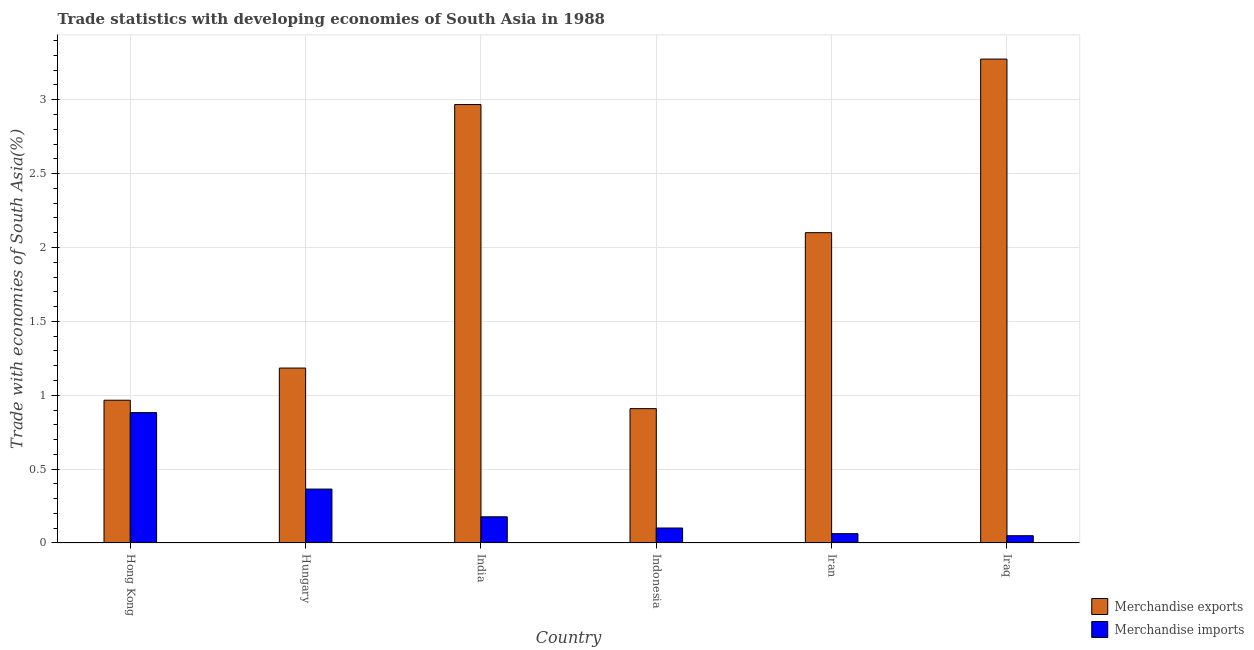How many different coloured bars are there?
Your answer should be very brief. 2. Are the number of bars on each tick of the X-axis equal?
Keep it short and to the point. Yes. How many bars are there on the 2nd tick from the left?
Make the answer very short. 2. How many bars are there on the 3rd tick from the right?
Keep it short and to the point. 2. What is the label of the 5th group of bars from the left?
Offer a very short reply. Iran. In how many cases, is the number of bars for a given country not equal to the number of legend labels?
Ensure brevity in your answer.  0. What is the merchandise exports in Iran?
Your answer should be very brief. 2.1. Across all countries, what is the maximum merchandise imports?
Provide a short and direct response. 0.88. Across all countries, what is the minimum merchandise imports?
Keep it short and to the point. 0.05. In which country was the merchandise exports maximum?
Provide a short and direct response. Iraq. In which country was the merchandise imports minimum?
Provide a succinct answer. Iraq. What is the total merchandise exports in the graph?
Offer a terse response. 11.4. What is the difference between the merchandise exports in Hungary and that in India?
Keep it short and to the point. -1.78. What is the difference between the merchandise exports in Indonesia and the merchandise imports in India?
Your response must be concise. 0.73. What is the average merchandise imports per country?
Provide a succinct answer. 0.27. What is the difference between the merchandise exports and merchandise imports in Iraq?
Your response must be concise. 3.23. What is the ratio of the merchandise exports in Hong Kong to that in Iran?
Keep it short and to the point. 0.46. Is the merchandise exports in Hong Kong less than that in Iran?
Provide a succinct answer. Yes. What is the difference between the highest and the second highest merchandise exports?
Offer a very short reply. 0.31. What is the difference between the highest and the lowest merchandise imports?
Your response must be concise. 0.83. What does the 2nd bar from the right in Hungary represents?
Offer a terse response. Merchandise exports. How many bars are there?
Make the answer very short. 12. How many countries are there in the graph?
Give a very brief answer. 6. How many legend labels are there?
Provide a short and direct response. 2. How are the legend labels stacked?
Ensure brevity in your answer.  Vertical. What is the title of the graph?
Offer a terse response. Trade statistics with developing economies of South Asia in 1988. What is the label or title of the Y-axis?
Provide a short and direct response. Trade with economies of South Asia(%). What is the Trade with economies of South Asia(%) of Merchandise exports in Hong Kong?
Ensure brevity in your answer.  0.97. What is the Trade with economies of South Asia(%) of Merchandise imports in Hong Kong?
Provide a succinct answer. 0.88. What is the Trade with economies of South Asia(%) of Merchandise exports in Hungary?
Your answer should be very brief. 1.18. What is the Trade with economies of South Asia(%) in Merchandise imports in Hungary?
Make the answer very short. 0.36. What is the Trade with economies of South Asia(%) in Merchandise exports in India?
Keep it short and to the point. 2.97. What is the Trade with economies of South Asia(%) in Merchandise imports in India?
Your answer should be compact. 0.18. What is the Trade with economies of South Asia(%) of Merchandise exports in Indonesia?
Your response must be concise. 0.91. What is the Trade with economies of South Asia(%) in Merchandise imports in Indonesia?
Your answer should be compact. 0.1. What is the Trade with economies of South Asia(%) in Merchandise exports in Iran?
Keep it short and to the point. 2.1. What is the Trade with economies of South Asia(%) in Merchandise imports in Iran?
Make the answer very short. 0.06. What is the Trade with economies of South Asia(%) in Merchandise exports in Iraq?
Offer a terse response. 3.27. What is the Trade with economies of South Asia(%) in Merchandise imports in Iraq?
Keep it short and to the point. 0.05. Across all countries, what is the maximum Trade with economies of South Asia(%) in Merchandise exports?
Make the answer very short. 3.27. Across all countries, what is the maximum Trade with economies of South Asia(%) in Merchandise imports?
Your response must be concise. 0.88. Across all countries, what is the minimum Trade with economies of South Asia(%) of Merchandise exports?
Offer a terse response. 0.91. Across all countries, what is the minimum Trade with economies of South Asia(%) of Merchandise imports?
Provide a succinct answer. 0.05. What is the total Trade with economies of South Asia(%) of Merchandise exports in the graph?
Offer a terse response. 11.4. What is the total Trade with economies of South Asia(%) in Merchandise imports in the graph?
Keep it short and to the point. 1.64. What is the difference between the Trade with economies of South Asia(%) of Merchandise exports in Hong Kong and that in Hungary?
Provide a succinct answer. -0.22. What is the difference between the Trade with economies of South Asia(%) in Merchandise imports in Hong Kong and that in Hungary?
Provide a succinct answer. 0.52. What is the difference between the Trade with economies of South Asia(%) in Merchandise exports in Hong Kong and that in India?
Offer a terse response. -2. What is the difference between the Trade with economies of South Asia(%) in Merchandise imports in Hong Kong and that in India?
Provide a short and direct response. 0.71. What is the difference between the Trade with economies of South Asia(%) of Merchandise exports in Hong Kong and that in Indonesia?
Keep it short and to the point. 0.06. What is the difference between the Trade with economies of South Asia(%) in Merchandise imports in Hong Kong and that in Indonesia?
Offer a very short reply. 0.78. What is the difference between the Trade with economies of South Asia(%) of Merchandise exports in Hong Kong and that in Iran?
Keep it short and to the point. -1.13. What is the difference between the Trade with economies of South Asia(%) in Merchandise imports in Hong Kong and that in Iran?
Provide a short and direct response. 0.82. What is the difference between the Trade with economies of South Asia(%) of Merchandise exports in Hong Kong and that in Iraq?
Keep it short and to the point. -2.31. What is the difference between the Trade with economies of South Asia(%) of Merchandise imports in Hong Kong and that in Iraq?
Your answer should be compact. 0.83. What is the difference between the Trade with economies of South Asia(%) in Merchandise exports in Hungary and that in India?
Give a very brief answer. -1.78. What is the difference between the Trade with economies of South Asia(%) in Merchandise imports in Hungary and that in India?
Your response must be concise. 0.19. What is the difference between the Trade with economies of South Asia(%) in Merchandise exports in Hungary and that in Indonesia?
Offer a very short reply. 0.27. What is the difference between the Trade with economies of South Asia(%) in Merchandise imports in Hungary and that in Indonesia?
Give a very brief answer. 0.26. What is the difference between the Trade with economies of South Asia(%) of Merchandise exports in Hungary and that in Iran?
Provide a succinct answer. -0.92. What is the difference between the Trade with economies of South Asia(%) of Merchandise imports in Hungary and that in Iran?
Provide a succinct answer. 0.3. What is the difference between the Trade with economies of South Asia(%) of Merchandise exports in Hungary and that in Iraq?
Make the answer very short. -2.09. What is the difference between the Trade with economies of South Asia(%) in Merchandise imports in Hungary and that in Iraq?
Provide a short and direct response. 0.32. What is the difference between the Trade with economies of South Asia(%) of Merchandise exports in India and that in Indonesia?
Offer a very short reply. 2.06. What is the difference between the Trade with economies of South Asia(%) of Merchandise imports in India and that in Indonesia?
Your response must be concise. 0.08. What is the difference between the Trade with economies of South Asia(%) in Merchandise exports in India and that in Iran?
Provide a succinct answer. 0.87. What is the difference between the Trade with economies of South Asia(%) of Merchandise imports in India and that in Iran?
Your answer should be compact. 0.11. What is the difference between the Trade with economies of South Asia(%) in Merchandise exports in India and that in Iraq?
Ensure brevity in your answer.  -0.31. What is the difference between the Trade with economies of South Asia(%) of Merchandise imports in India and that in Iraq?
Ensure brevity in your answer.  0.13. What is the difference between the Trade with economies of South Asia(%) in Merchandise exports in Indonesia and that in Iran?
Your answer should be very brief. -1.19. What is the difference between the Trade with economies of South Asia(%) in Merchandise imports in Indonesia and that in Iran?
Offer a terse response. 0.04. What is the difference between the Trade with economies of South Asia(%) of Merchandise exports in Indonesia and that in Iraq?
Provide a short and direct response. -2.37. What is the difference between the Trade with economies of South Asia(%) of Merchandise imports in Indonesia and that in Iraq?
Offer a terse response. 0.05. What is the difference between the Trade with economies of South Asia(%) in Merchandise exports in Iran and that in Iraq?
Provide a short and direct response. -1.17. What is the difference between the Trade with economies of South Asia(%) in Merchandise imports in Iran and that in Iraq?
Provide a succinct answer. 0.01. What is the difference between the Trade with economies of South Asia(%) of Merchandise exports in Hong Kong and the Trade with economies of South Asia(%) of Merchandise imports in Hungary?
Keep it short and to the point. 0.6. What is the difference between the Trade with economies of South Asia(%) of Merchandise exports in Hong Kong and the Trade with economies of South Asia(%) of Merchandise imports in India?
Keep it short and to the point. 0.79. What is the difference between the Trade with economies of South Asia(%) of Merchandise exports in Hong Kong and the Trade with economies of South Asia(%) of Merchandise imports in Indonesia?
Keep it short and to the point. 0.86. What is the difference between the Trade with economies of South Asia(%) of Merchandise exports in Hong Kong and the Trade with economies of South Asia(%) of Merchandise imports in Iran?
Your response must be concise. 0.9. What is the difference between the Trade with economies of South Asia(%) in Merchandise exports in Hong Kong and the Trade with economies of South Asia(%) in Merchandise imports in Iraq?
Your answer should be compact. 0.92. What is the difference between the Trade with economies of South Asia(%) of Merchandise exports in Hungary and the Trade with economies of South Asia(%) of Merchandise imports in Indonesia?
Offer a very short reply. 1.08. What is the difference between the Trade with economies of South Asia(%) in Merchandise exports in Hungary and the Trade with economies of South Asia(%) in Merchandise imports in Iran?
Keep it short and to the point. 1.12. What is the difference between the Trade with economies of South Asia(%) of Merchandise exports in Hungary and the Trade with economies of South Asia(%) of Merchandise imports in Iraq?
Ensure brevity in your answer.  1.13. What is the difference between the Trade with economies of South Asia(%) in Merchandise exports in India and the Trade with economies of South Asia(%) in Merchandise imports in Indonesia?
Your answer should be compact. 2.87. What is the difference between the Trade with economies of South Asia(%) of Merchandise exports in India and the Trade with economies of South Asia(%) of Merchandise imports in Iran?
Your response must be concise. 2.9. What is the difference between the Trade with economies of South Asia(%) of Merchandise exports in India and the Trade with economies of South Asia(%) of Merchandise imports in Iraq?
Offer a very short reply. 2.92. What is the difference between the Trade with economies of South Asia(%) in Merchandise exports in Indonesia and the Trade with economies of South Asia(%) in Merchandise imports in Iran?
Give a very brief answer. 0.85. What is the difference between the Trade with economies of South Asia(%) of Merchandise exports in Indonesia and the Trade with economies of South Asia(%) of Merchandise imports in Iraq?
Ensure brevity in your answer.  0.86. What is the difference between the Trade with economies of South Asia(%) in Merchandise exports in Iran and the Trade with economies of South Asia(%) in Merchandise imports in Iraq?
Offer a very short reply. 2.05. What is the average Trade with economies of South Asia(%) of Merchandise exports per country?
Provide a short and direct response. 1.9. What is the average Trade with economies of South Asia(%) of Merchandise imports per country?
Your answer should be compact. 0.27. What is the difference between the Trade with economies of South Asia(%) of Merchandise exports and Trade with economies of South Asia(%) of Merchandise imports in Hong Kong?
Make the answer very short. 0.08. What is the difference between the Trade with economies of South Asia(%) in Merchandise exports and Trade with economies of South Asia(%) in Merchandise imports in Hungary?
Keep it short and to the point. 0.82. What is the difference between the Trade with economies of South Asia(%) of Merchandise exports and Trade with economies of South Asia(%) of Merchandise imports in India?
Ensure brevity in your answer.  2.79. What is the difference between the Trade with economies of South Asia(%) of Merchandise exports and Trade with economies of South Asia(%) of Merchandise imports in Indonesia?
Provide a short and direct response. 0.81. What is the difference between the Trade with economies of South Asia(%) of Merchandise exports and Trade with economies of South Asia(%) of Merchandise imports in Iran?
Offer a terse response. 2.04. What is the difference between the Trade with economies of South Asia(%) in Merchandise exports and Trade with economies of South Asia(%) in Merchandise imports in Iraq?
Provide a short and direct response. 3.23. What is the ratio of the Trade with economies of South Asia(%) of Merchandise exports in Hong Kong to that in Hungary?
Offer a very short reply. 0.82. What is the ratio of the Trade with economies of South Asia(%) of Merchandise imports in Hong Kong to that in Hungary?
Offer a terse response. 2.42. What is the ratio of the Trade with economies of South Asia(%) in Merchandise exports in Hong Kong to that in India?
Your answer should be compact. 0.33. What is the ratio of the Trade with economies of South Asia(%) in Merchandise imports in Hong Kong to that in India?
Give a very brief answer. 4.98. What is the ratio of the Trade with economies of South Asia(%) in Merchandise exports in Hong Kong to that in Indonesia?
Offer a terse response. 1.06. What is the ratio of the Trade with economies of South Asia(%) of Merchandise imports in Hong Kong to that in Indonesia?
Provide a succinct answer. 8.7. What is the ratio of the Trade with economies of South Asia(%) in Merchandise exports in Hong Kong to that in Iran?
Ensure brevity in your answer.  0.46. What is the ratio of the Trade with economies of South Asia(%) of Merchandise imports in Hong Kong to that in Iran?
Offer a terse response. 13.99. What is the ratio of the Trade with economies of South Asia(%) of Merchandise exports in Hong Kong to that in Iraq?
Your answer should be compact. 0.29. What is the ratio of the Trade with economies of South Asia(%) in Merchandise imports in Hong Kong to that in Iraq?
Your answer should be very brief. 17.88. What is the ratio of the Trade with economies of South Asia(%) of Merchandise exports in Hungary to that in India?
Make the answer very short. 0.4. What is the ratio of the Trade with economies of South Asia(%) of Merchandise imports in Hungary to that in India?
Make the answer very short. 2.06. What is the ratio of the Trade with economies of South Asia(%) in Merchandise exports in Hungary to that in Indonesia?
Keep it short and to the point. 1.3. What is the ratio of the Trade with economies of South Asia(%) in Merchandise imports in Hungary to that in Indonesia?
Keep it short and to the point. 3.6. What is the ratio of the Trade with economies of South Asia(%) in Merchandise exports in Hungary to that in Iran?
Offer a very short reply. 0.56. What is the ratio of the Trade with economies of South Asia(%) in Merchandise imports in Hungary to that in Iran?
Make the answer very short. 5.78. What is the ratio of the Trade with economies of South Asia(%) of Merchandise exports in Hungary to that in Iraq?
Ensure brevity in your answer.  0.36. What is the ratio of the Trade with economies of South Asia(%) of Merchandise imports in Hungary to that in Iraq?
Your answer should be compact. 7.39. What is the ratio of the Trade with economies of South Asia(%) in Merchandise exports in India to that in Indonesia?
Provide a succinct answer. 3.26. What is the ratio of the Trade with economies of South Asia(%) in Merchandise imports in India to that in Indonesia?
Provide a succinct answer. 1.75. What is the ratio of the Trade with economies of South Asia(%) of Merchandise exports in India to that in Iran?
Provide a short and direct response. 1.41. What is the ratio of the Trade with economies of South Asia(%) of Merchandise imports in India to that in Iran?
Keep it short and to the point. 2.81. What is the ratio of the Trade with economies of South Asia(%) in Merchandise exports in India to that in Iraq?
Give a very brief answer. 0.91. What is the ratio of the Trade with economies of South Asia(%) in Merchandise imports in India to that in Iraq?
Provide a succinct answer. 3.59. What is the ratio of the Trade with economies of South Asia(%) in Merchandise exports in Indonesia to that in Iran?
Offer a terse response. 0.43. What is the ratio of the Trade with economies of South Asia(%) in Merchandise imports in Indonesia to that in Iran?
Your answer should be very brief. 1.61. What is the ratio of the Trade with economies of South Asia(%) of Merchandise exports in Indonesia to that in Iraq?
Provide a succinct answer. 0.28. What is the ratio of the Trade with economies of South Asia(%) of Merchandise imports in Indonesia to that in Iraq?
Ensure brevity in your answer.  2.06. What is the ratio of the Trade with economies of South Asia(%) of Merchandise exports in Iran to that in Iraq?
Give a very brief answer. 0.64. What is the ratio of the Trade with economies of South Asia(%) of Merchandise imports in Iran to that in Iraq?
Provide a succinct answer. 1.28. What is the difference between the highest and the second highest Trade with economies of South Asia(%) in Merchandise exports?
Make the answer very short. 0.31. What is the difference between the highest and the second highest Trade with economies of South Asia(%) of Merchandise imports?
Make the answer very short. 0.52. What is the difference between the highest and the lowest Trade with economies of South Asia(%) in Merchandise exports?
Ensure brevity in your answer.  2.37. What is the difference between the highest and the lowest Trade with economies of South Asia(%) of Merchandise imports?
Make the answer very short. 0.83. 